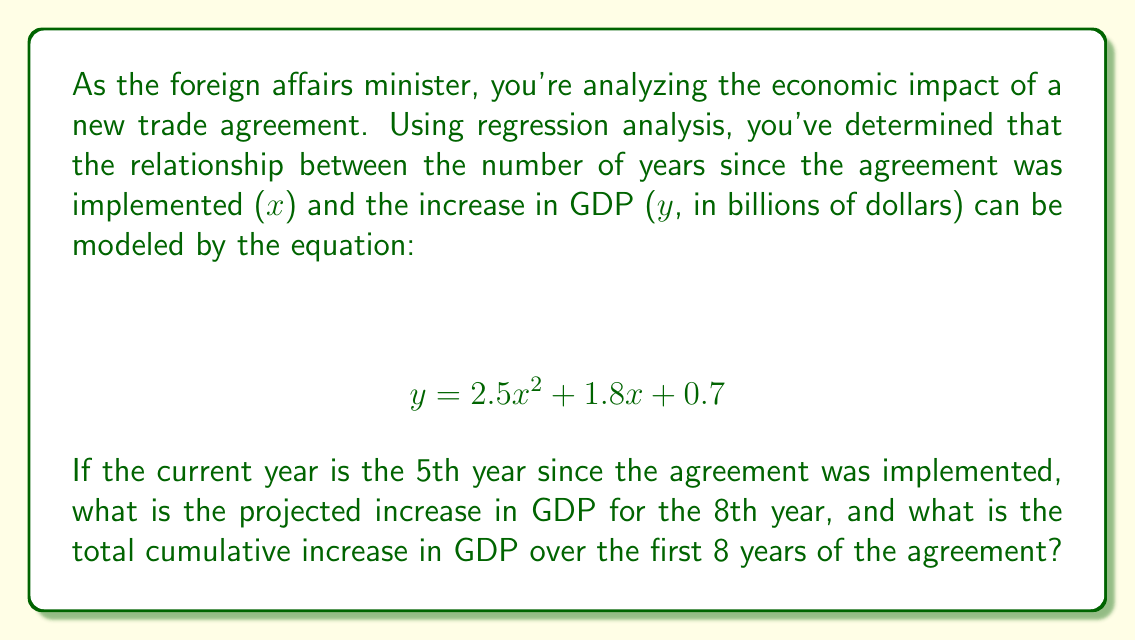Help me with this question. Let's approach this step-by-step:

1) First, we need to calculate the projected increase in GDP for the 8th year:
   - Substitute x = 8 into the given equation:
   $$ y = 2.5(8)^2 + 1.8(8) + 0.7 $$
   $$ y = 2.5(64) + 14.4 + 0.7 $$
   $$ y = 160 + 14.4 + 0.7 = 175.1 $$

2) Now, to find the total cumulative increase over 8 years, we need to sum the increases for each year from 1 to 8:
   $$ \sum_{x=1}^{8} (2.5x^2 + 1.8x + 0.7) $$

3) We can use the formulas for the sum of squares and sum of natural numbers:
   $$ \sum_{x=1}^{n} x^2 = \frac{n(n+1)(2n+1)}{6} $$
   $$ \sum_{x=1}^{n} x = \frac{n(n+1)}{2} $$

4) Substituting n = 8 into our equation:
   $$ 2.5 \cdot \frac{8(9)(17)}{6} + 1.8 \cdot \frac{8(9)}{2} + 0.7 \cdot 8 $$

5) Simplifying:
   $$ 2.5 \cdot 204 + 1.8 \cdot 36 + 5.6 $$
   $$ 510 + 64.8 + 5.6 = 580.4 $$

Therefore, the projected increase for the 8th year is $175.1 billion, and the total cumulative increase over 8 years is $580.4 billion.
Answer: $175.1 billion for 8th year; $580.4 billion cumulative over 8 years 